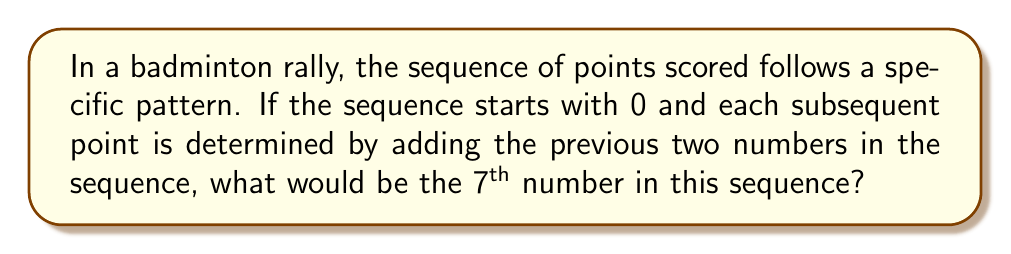Provide a solution to this math problem. Let's break this down step-by-step:

1) We start with 0 as the first number in the sequence.

2) The second number in a Fibonacci-like sequence is typically 1.

3) Now, we can generate the rest of the sequence:
   - 3rd number: $0 + 1 = 1$
   - 4th number: $1 + 1 = 2$
   - 5th number: $1 + 2 = 3$
   - 6th number: $2 + 3 = 5$
   - 7th number: $3 + 5 = 8$

4) We can represent this sequence mathematically as:

   $$a_n = a_{n-1} + a_{n-2}$$

   Where $a_n$ is the nth term in the sequence, $a_{n-1}$ is the previous term, and $a_{n-2}$ is the term before that.

5) The complete sequence up to the 7th term is:

   $$0, 1, 1, 2, 3, 5, 8$$

Therefore, the 7th number in the sequence is 8.
Answer: 8 